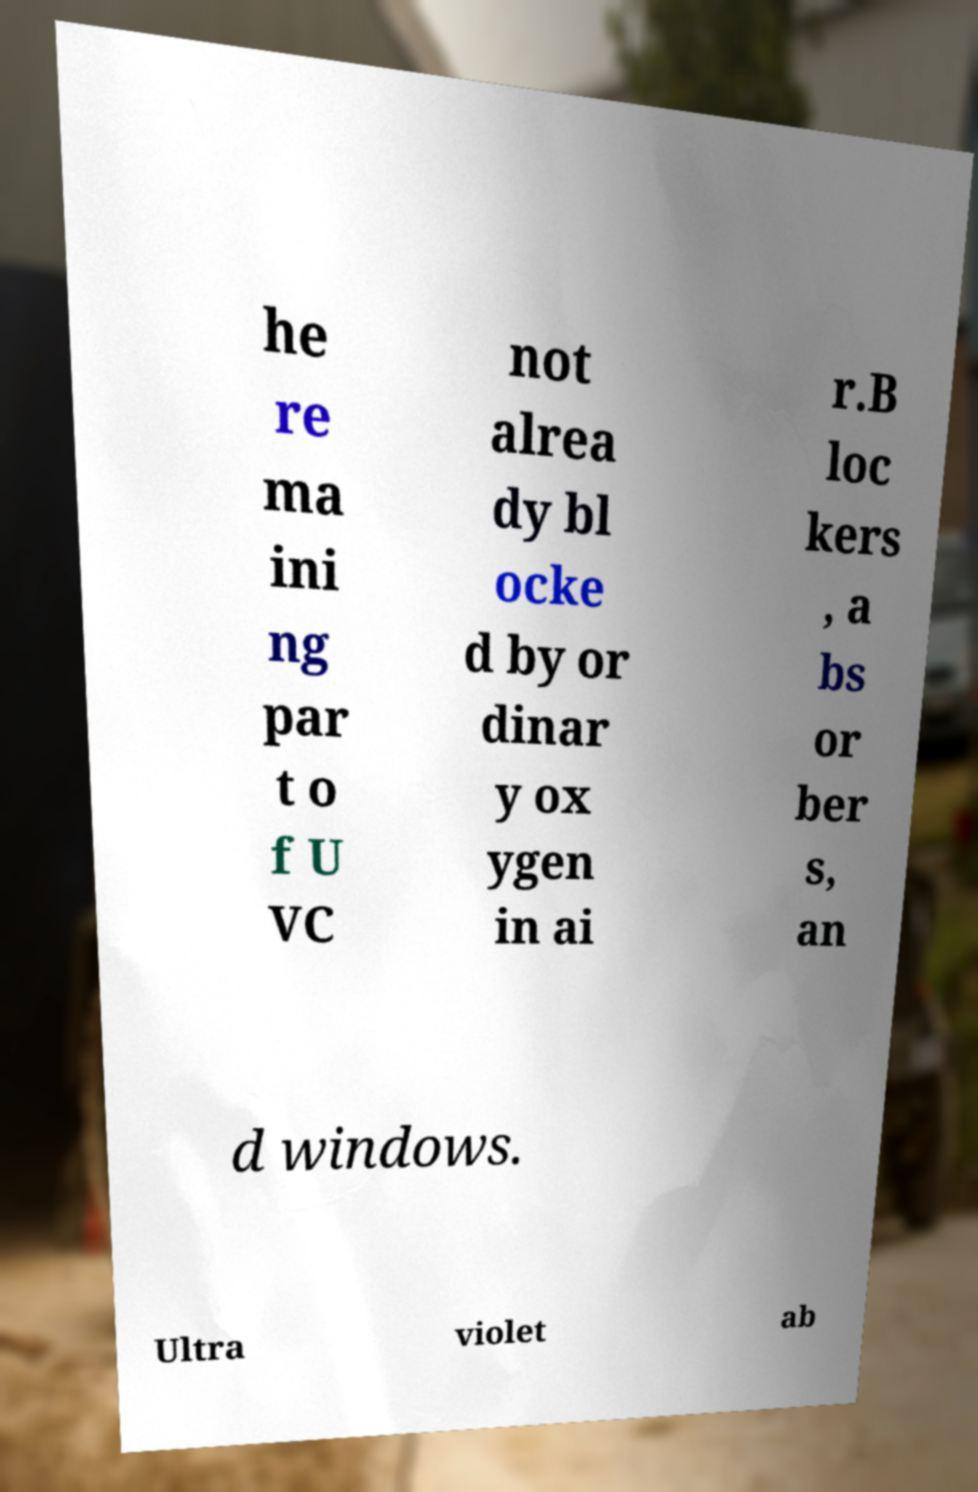There's text embedded in this image that I need extracted. Can you transcribe it verbatim? he re ma ini ng par t o f U VC not alrea dy bl ocke d by or dinar y ox ygen in ai r.B loc kers , a bs or ber s, an d windows. Ultra violet ab 